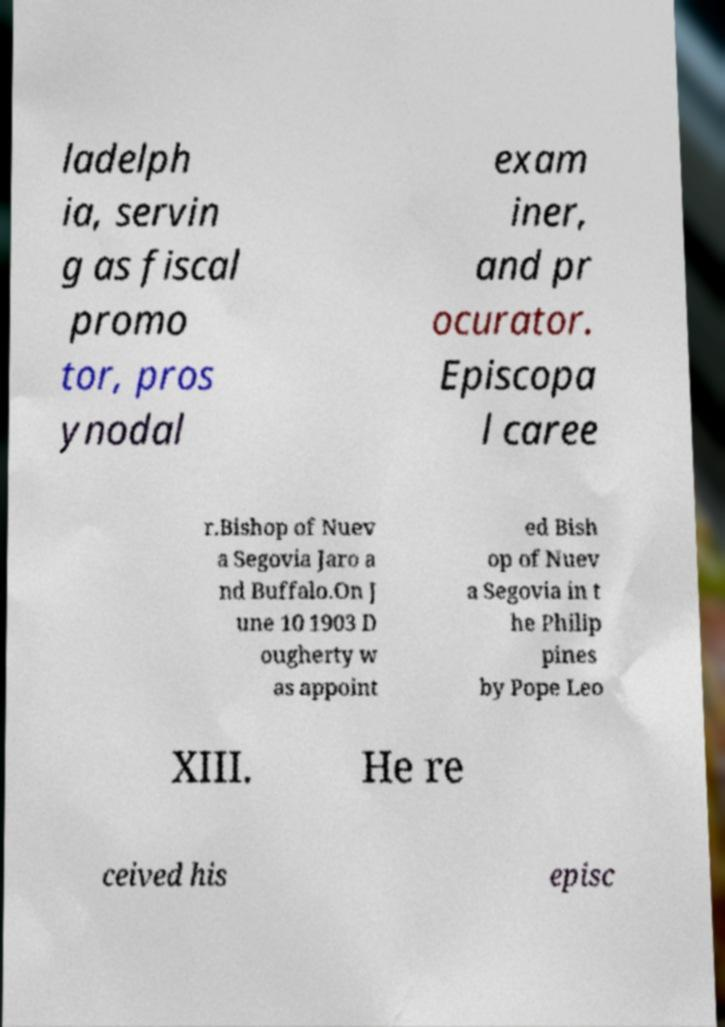Can you read and provide the text displayed in the image?This photo seems to have some interesting text. Can you extract and type it out for me? ladelph ia, servin g as fiscal promo tor, pros ynodal exam iner, and pr ocurator. Episcopa l caree r.Bishop of Nuev a Segovia Jaro a nd Buffalo.On J une 10 1903 D ougherty w as appoint ed Bish op of Nuev a Segovia in t he Philip pines by Pope Leo XIII. He re ceived his episc 